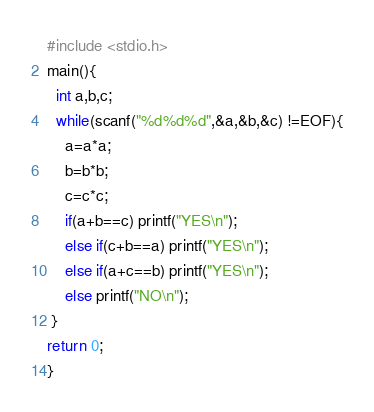<code> <loc_0><loc_0><loc_500><loc_500><_C_>#include <stdio.h>
main(){
  int a,b,c;
  while(scanf("%d%d%d",&a,&b,&c) !=EOF){
    a=a*a;
    b=b*b;
    c=c*c;
    if(a+b==c) printf("YES\n");
    else if(c+b==a) printf("YES\n");
    else if(a+c==b) printf("YES\n");
    else printf("NO\n");
 }
return 0; 
}</code> 